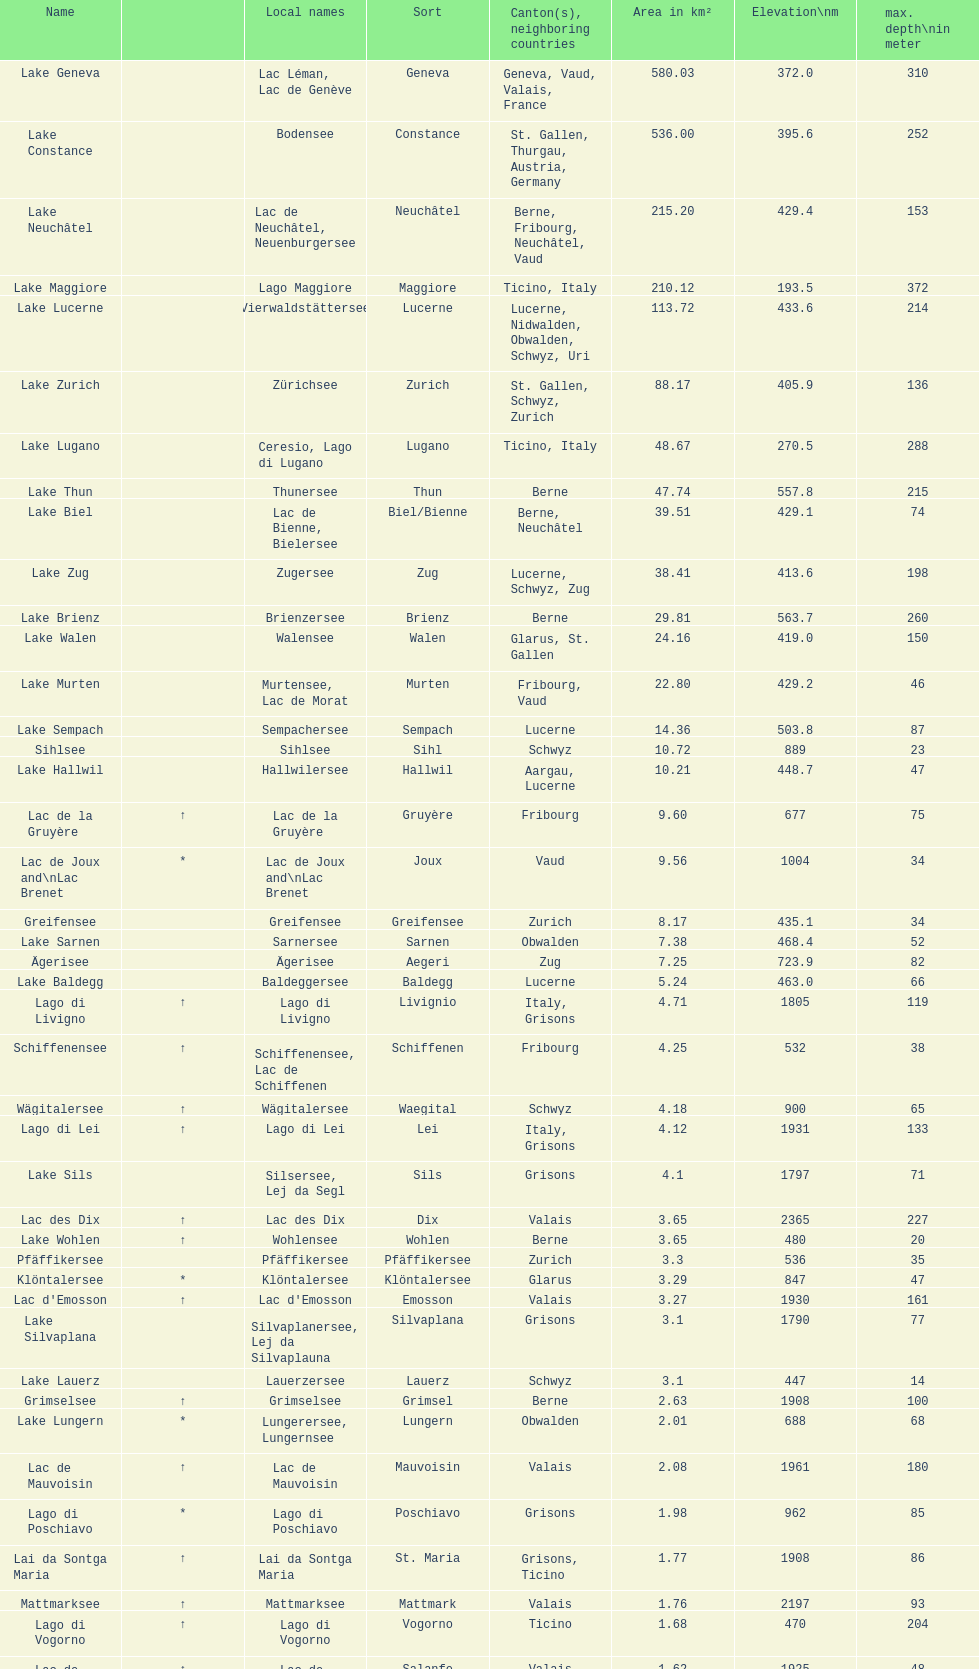Which lake has at least 580 area in km²? Lake Geneva. 